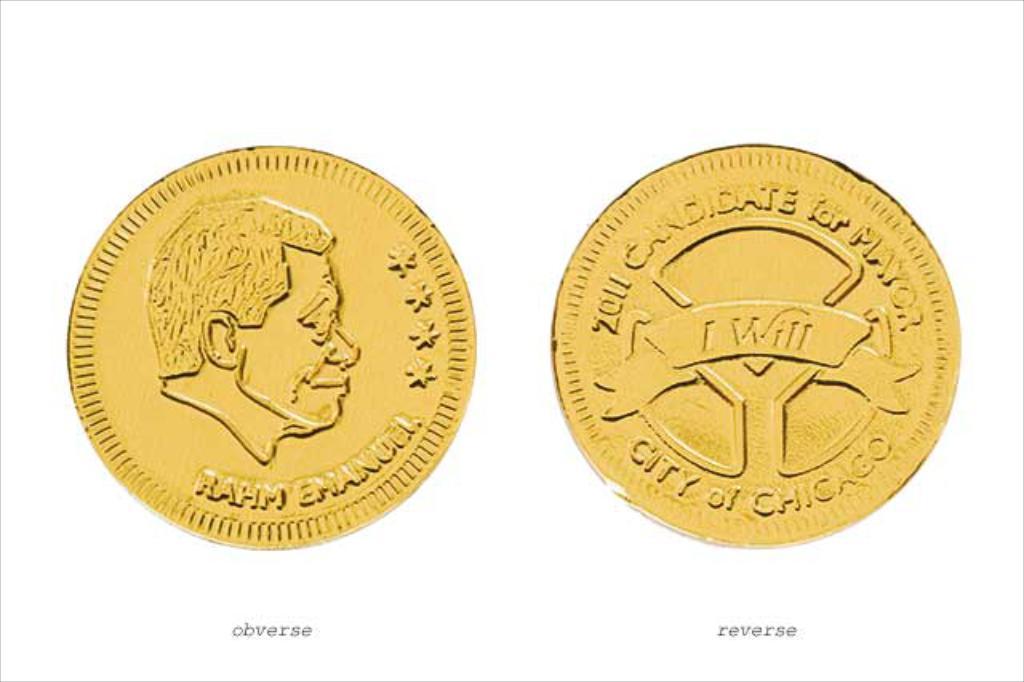What words are on the scroll on the center of the coin?
Offer a very short reply. I will. Is chicago mentioned?
Provide a short and direct response. Yes. 